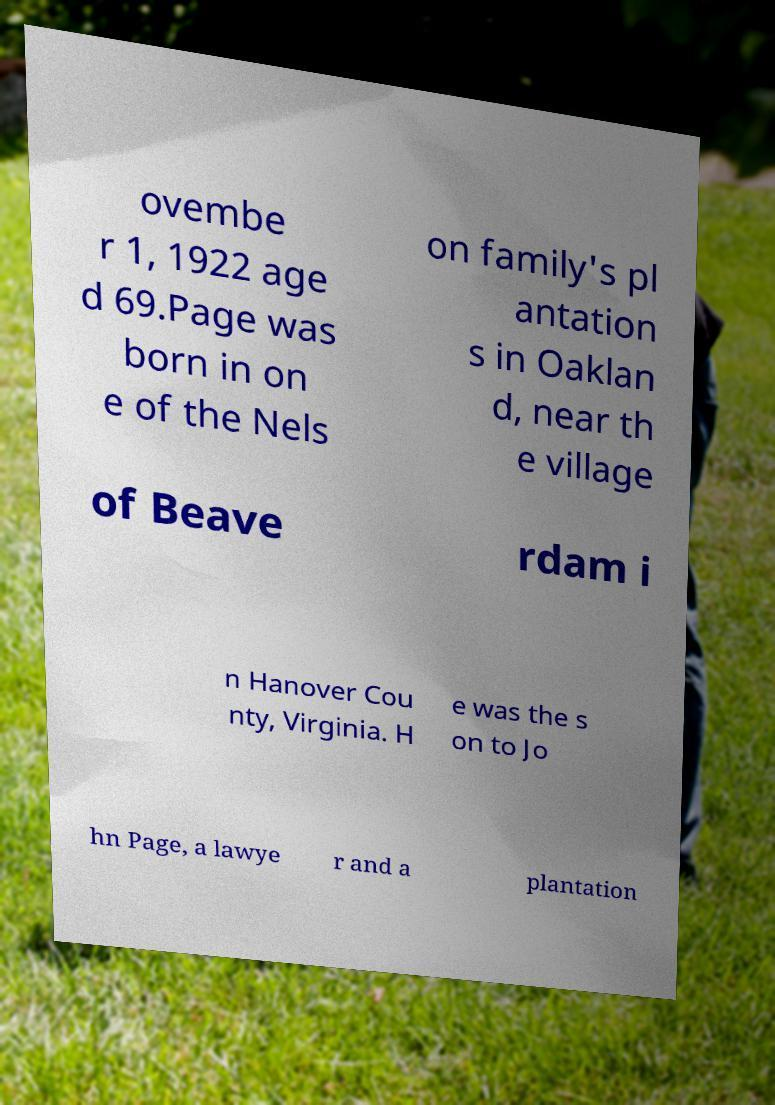Can you read and provide the text displayed in the image?This photo seems to have some interesting text. Can you extract and type it out for me? ovembe r 1, 1922 age d 69.Page was born in on e of the Nels on family's pl antation s in Oaklan d, near th e village of Beave rdam i n Hanover Cou nty, Virginia. H e was the s on to Jo hn Page, a lawye r and a plantation 